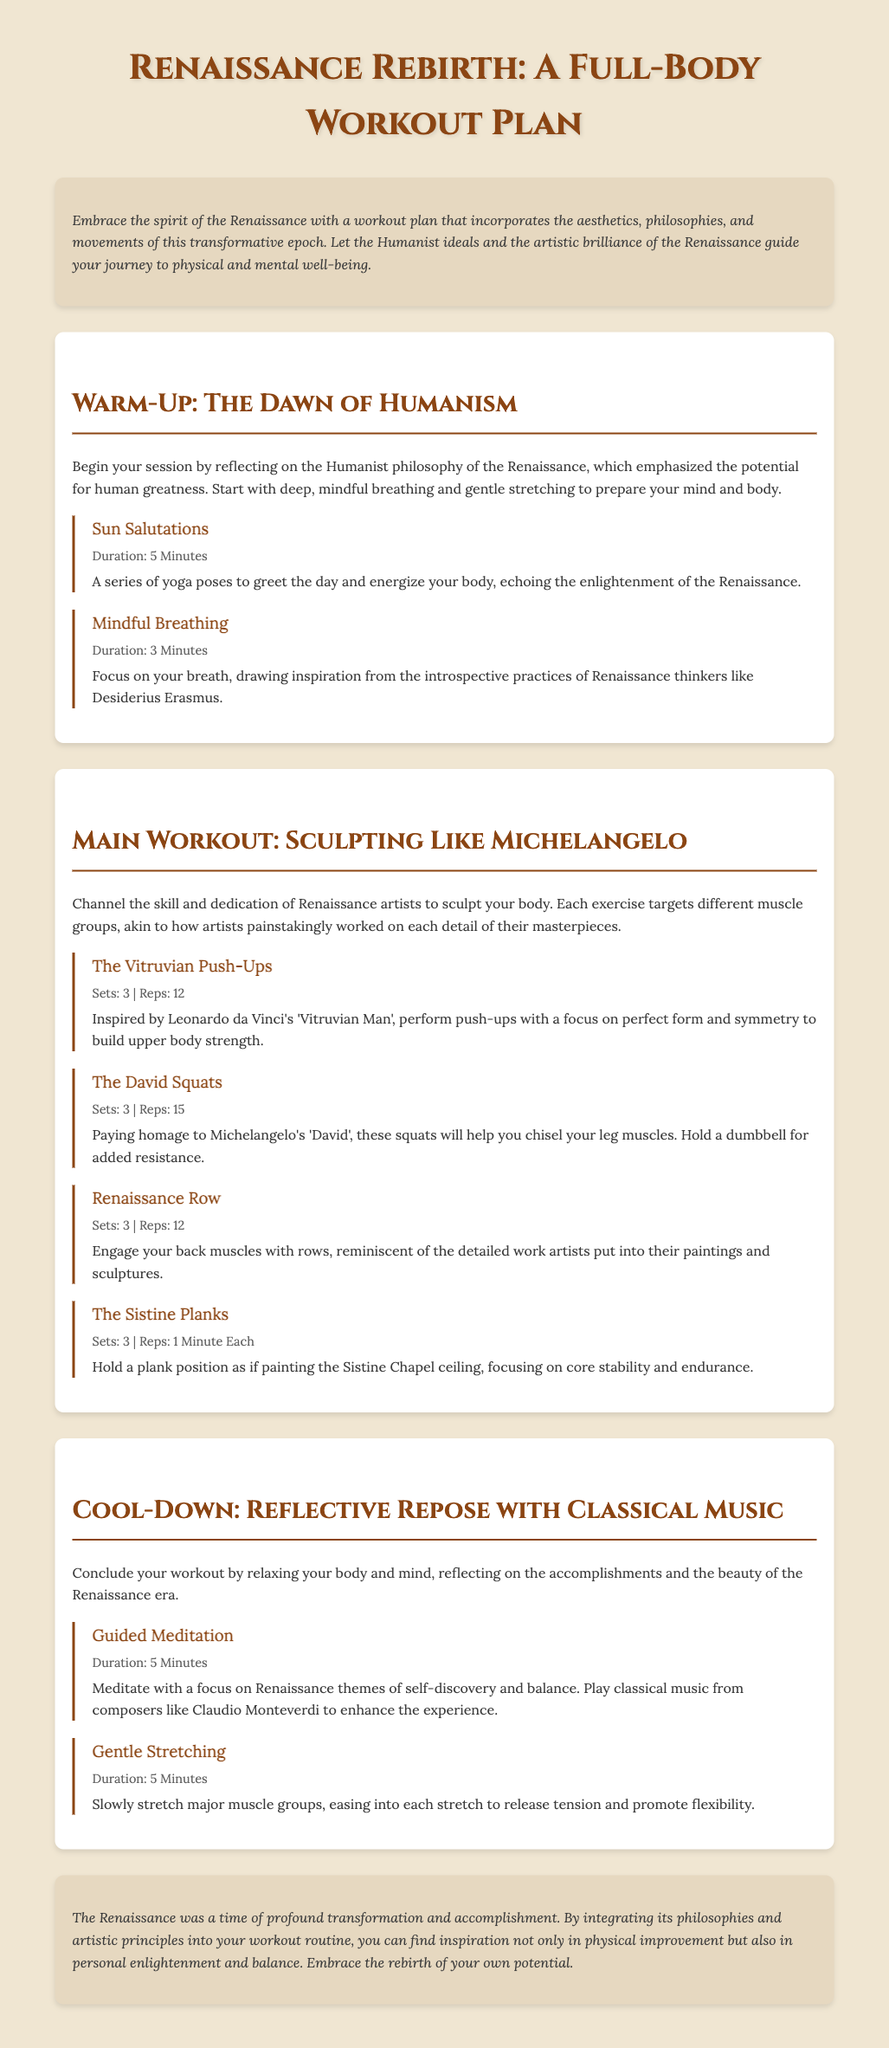What is the title of the workout plan? The title is found in the main heading of the document.
Answer: Renaissance Rebirth: A Full-Body Workout Plan How long should you perform Sun Salutations? The duration is specified in the details of the exercise section.
Answer: 5 Minutes Which exercise is inspired by the Vitruvian Man? The named exercise relates directly to the artwork mentioned in its description.
Answer: The Vitruvian Push-Ups How many sets are recommended for The David Squats? The details state the number of sets for this exercise.
Answer: 3 What type of music is suggested for the guided meditation? The document mentions a specific influence for the music in the cool-down section.
Answer: Classical music What is the main theme of the cool-down section? The focus of the cool-down relates to relaxation and reflection described in the text.
Answer: Reflective Repose Which philosophical movement does this workout plan reference? The introduction highlights a specific philosophical belief system from the Renaissance.
Answer: Humanism How many exercises are listed in the main workout section? The document contains a specific number of exercises detailed under the main workout.
Answer: 4 